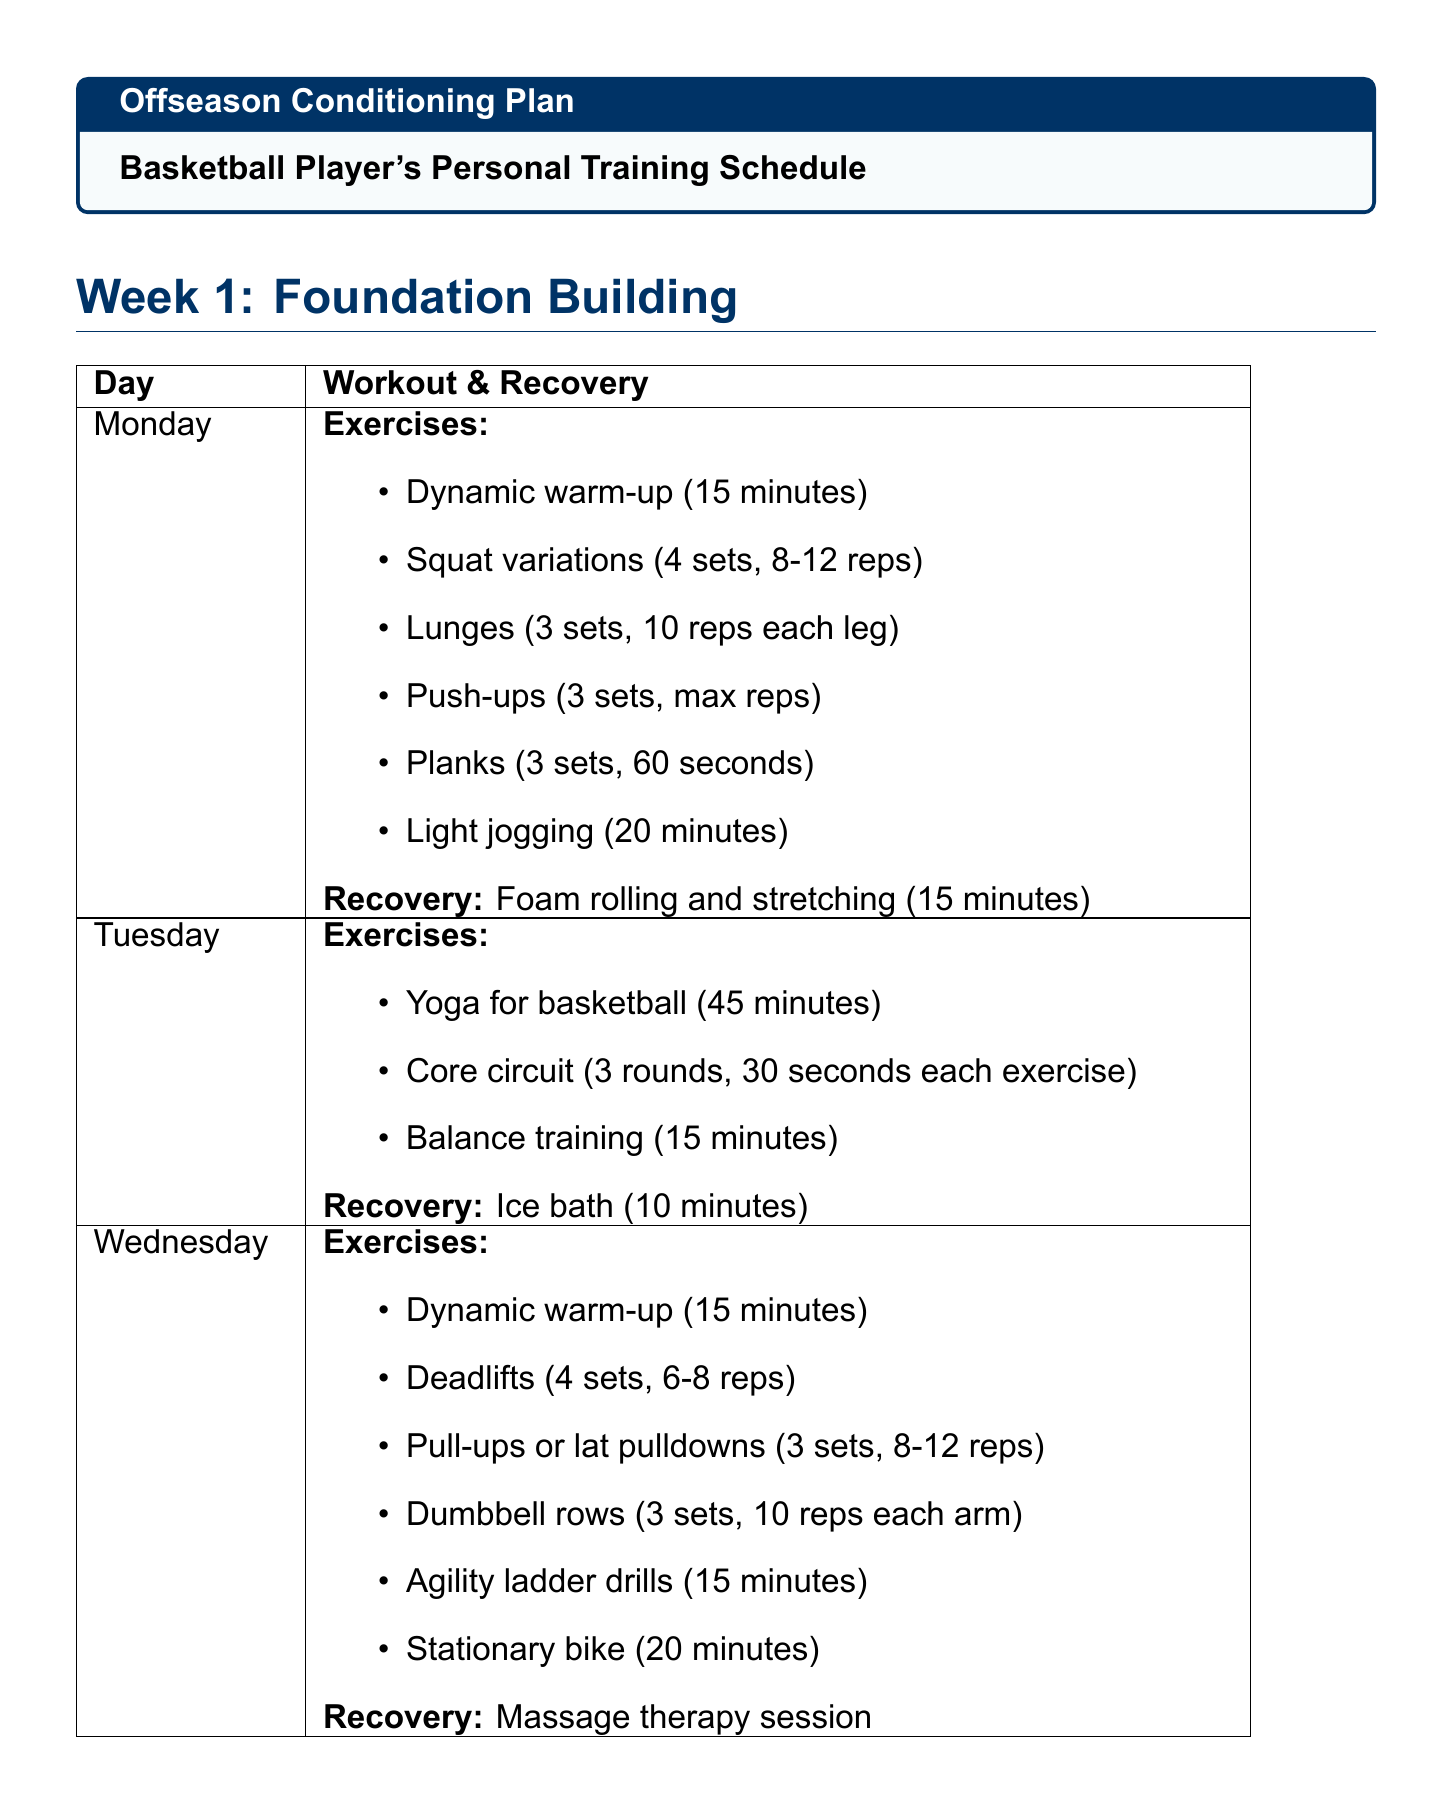What is the focus of week 1? The focus of week 1 is mentioned specifically in the document as "Foundation Building."
Answer: Foundation Building How many sets of squats are included on Monday of week 1? The document specifies that there are 4 sets of squat variations on Monday.
Answer: 4 sets What is the duration of the yoga session on Tuesday of week 1? The duration for yoga on Tuesday is clearly stated as 45 minutes.
Answer: 45 minutes How many hours of sleep optimization are recommended? The document recommends 8-10 hours per night for sleep optimization.
Answer: 8-10 hours What type of therapy is used for recovery on Wednesday of week 2? The document states that cryotherapy is used for recovery on that day.
Answer: Cryotherapy How many exercises are included in the core circuit on Tuesday of week 1? The core circuit consists of 3 rounds of a certain number of exercises as detailed in the document.
Answer: 3 rounds What recovery technique is suggested for Friday of week 2? The document mentions that stretching and mobility work is the recovery technique for that day.
Answer: Stretching and mobility work What is the daily calorie intake range mentioned in the nutrition guidelines? The range for daily calorie intake is directly provided in the document.
Answer: 3500-4000 calories 